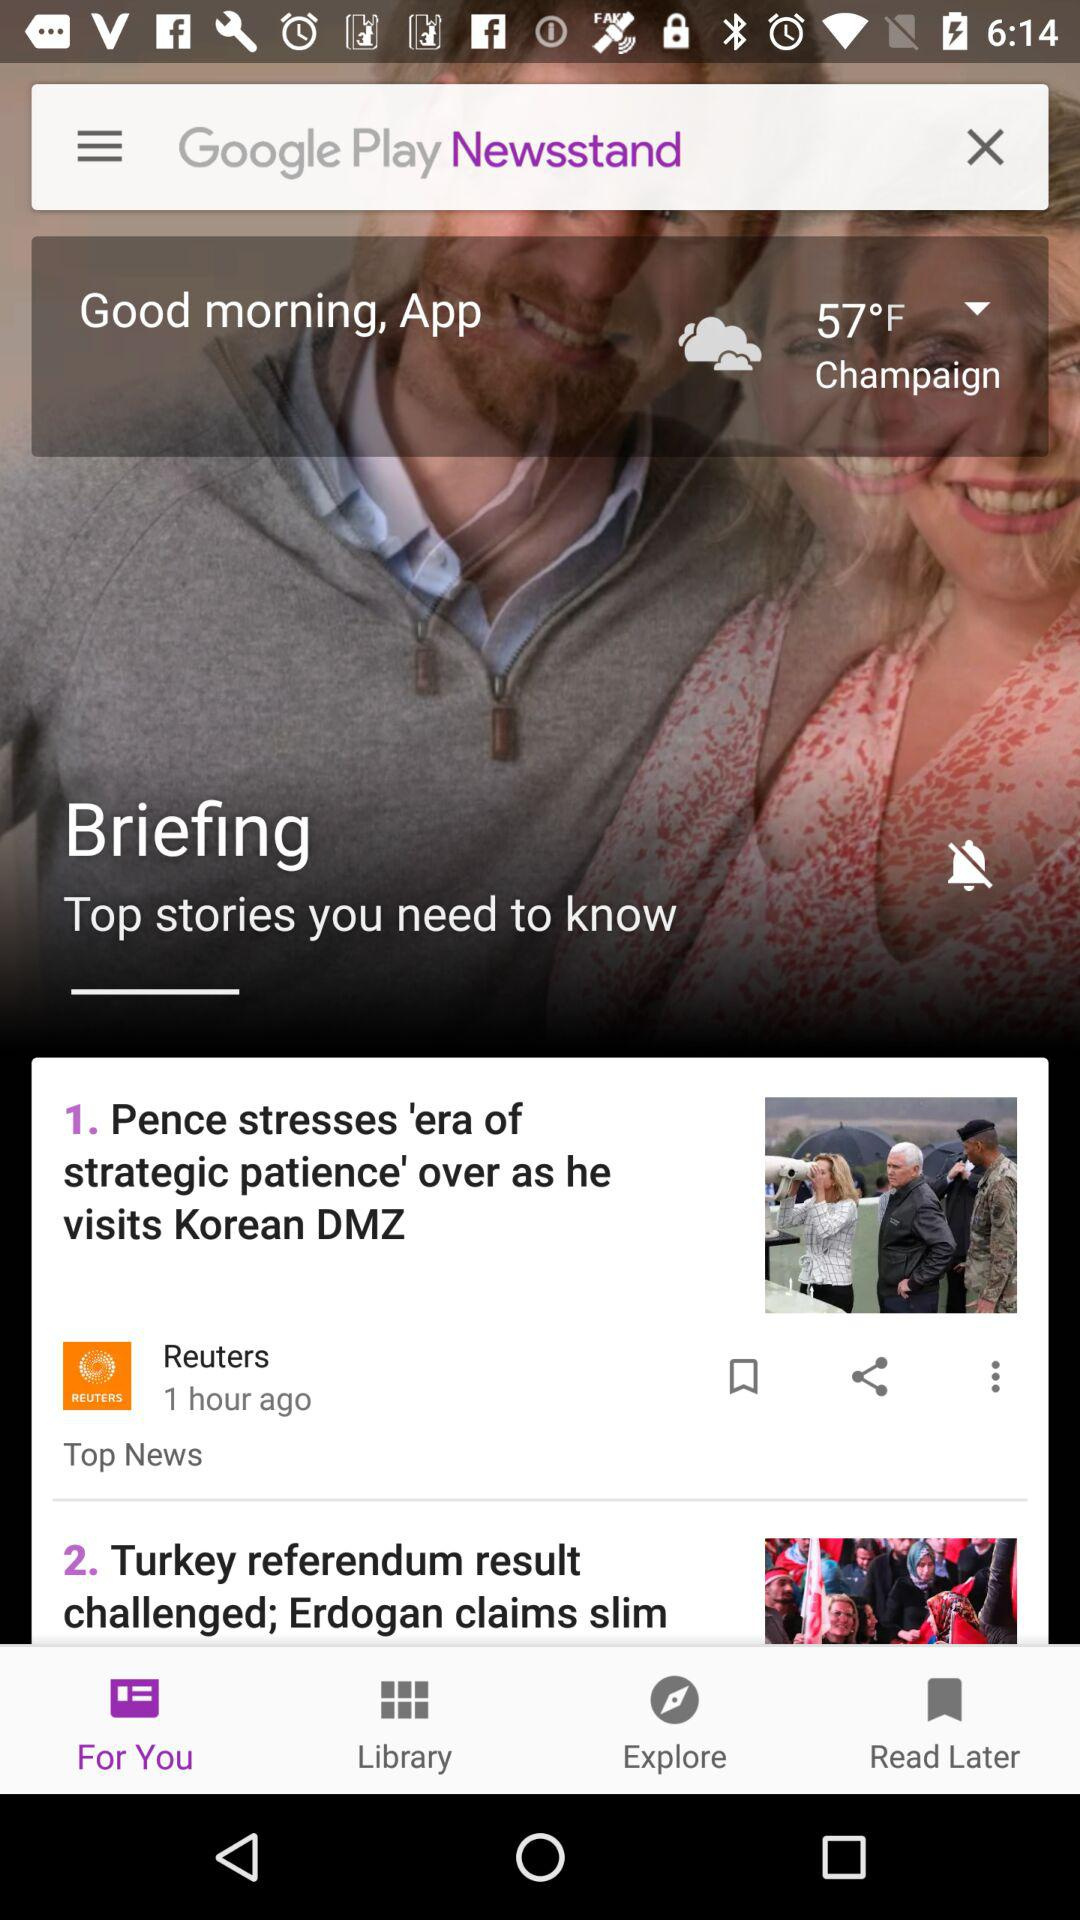How many stories are there in the news feed?
Answer the question using a single word or phrase. 2 